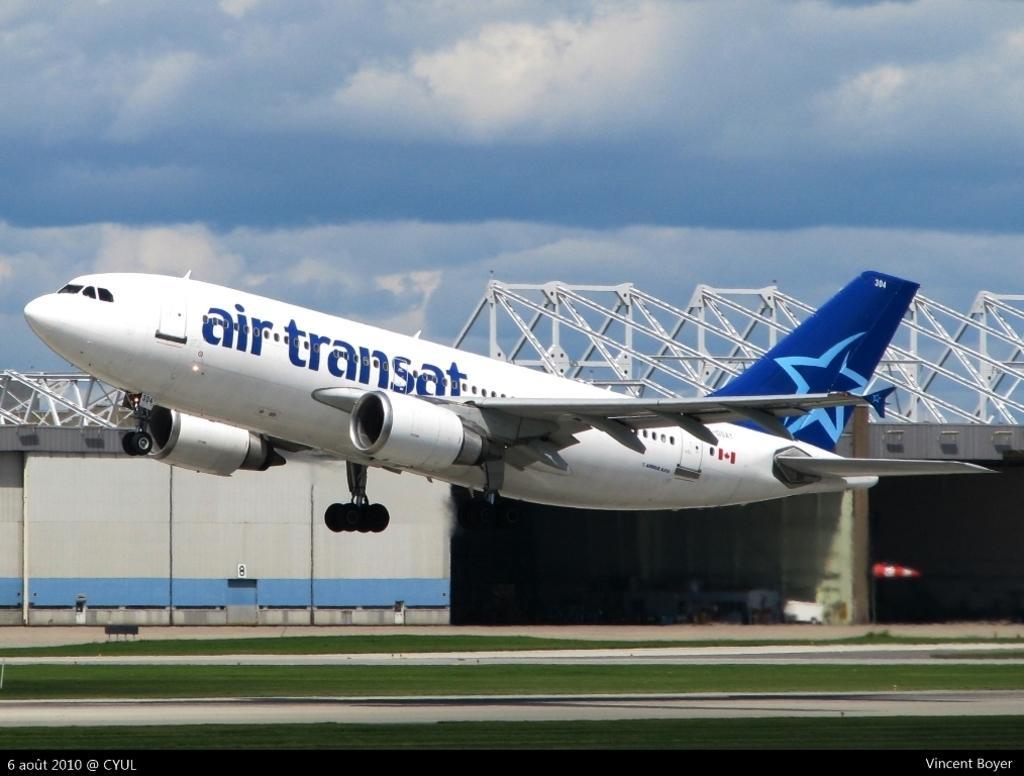In one or two sentences, can you explain what this image depicts? In this picture there is an aeroplane in the center of the image and there is grass land at the bottom side of the image, there is boundary in the background area of the image. 